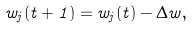<formula> <loc_0><loc_0><loc_500><loc_500>w _ { j } ( t + 1 ) = w _ { j } ( t ) - \Delta w ,</formula> 